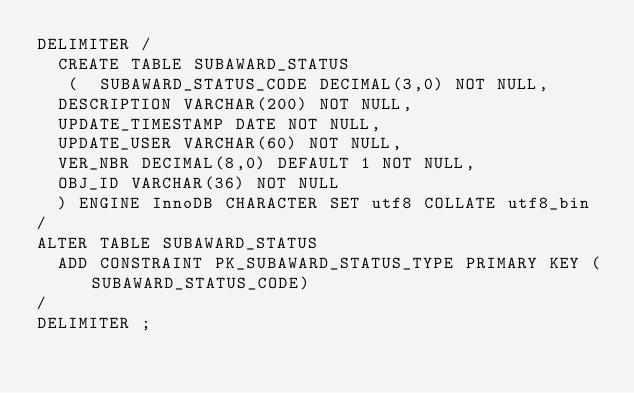<code> <loc_0><loc_0><loc_500><loc_500><_SQL_>DELIMITER /
  CREATE TABLE SUBAWARD_STATUS 
   (	SUBAWARD_STATUS_CODE DECIMAL(3,0) NOT NULL, 
	DESCRIPTION VARCHAR(200) NOT NULL, 
	UPDATE_TIMESTAMP DATE NOT NULL, 
	UPDATE_USER VARCHAR(60) NOT NULL, 
	VER_NBR DECIMAL(8,0) DEFAULT 1 NOT NULL, 
	OBJ_ID VARCHAR(36) NOT NULL 
  ) ENGINE InnoDB CHARACTER SET utf8 COLLATE utf8_bin
/
ALTER TABLE SUBAWARD_STATUS
  ADD CONSTRAINT PK_SUBAWARD_STATUS_TYPE PRIMARY KEY (SUBAWARD_STATUS_CODE)
/
DELIMITER ;
</code> 